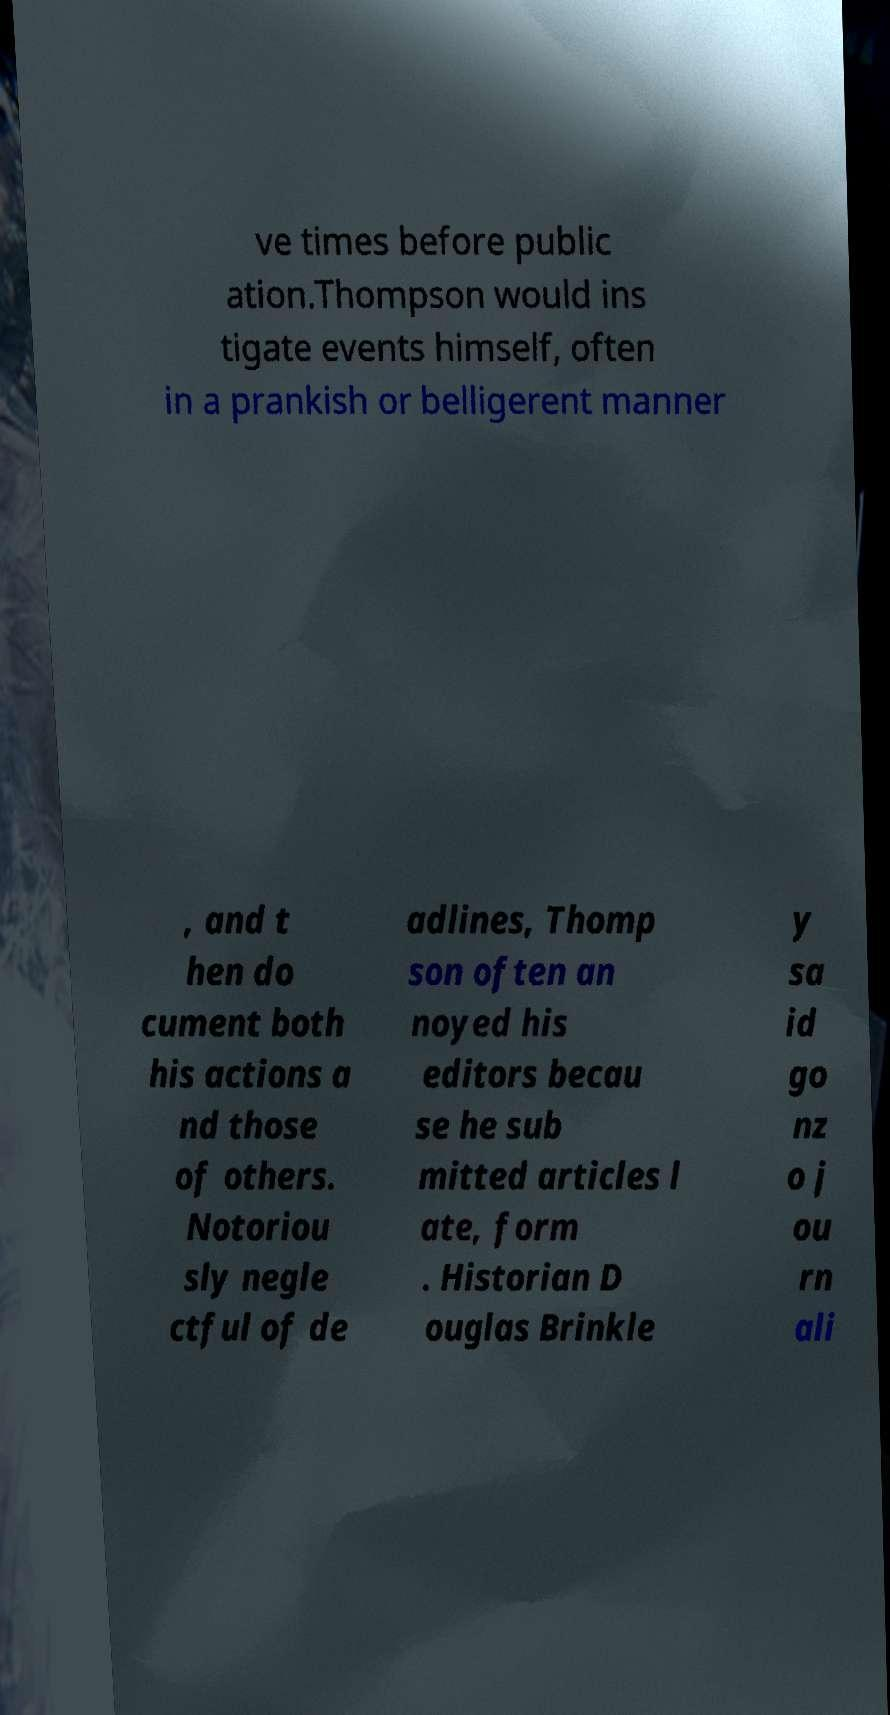There's text embedded in this image that I need extracted. Can you transcribe it verbatim? ve times before public ation.Thompson would ins tigate events himself, often in a prankish or belligerent manner , and t hen do cument both his actions a nd those of others. Notoriou sly negle ctful of de adlines, Thomp son often an noyed his editors becau se he sub mitted articles l ate, form . Historian D ouglas Brinkle y sa id go nz o j ou rn ali 